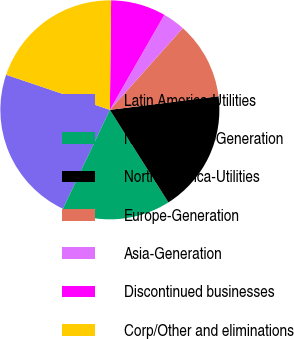Convert chart. <chart><loc_0><loc_0><loc_500><loc_500><pie_chart><fcel>Latin America-Utilities<fcel>North America-Generation<fcel>North America-Utilities<fcel>Europe-Generation<fcel>Asia-Generation<fcel>Discontinued businesses<fcel>Corp/Other and eliminations<nl><fcel>23.14%<fcel>16.03%<fcel>18.01%<fcel>11.42%<fcel>3.31%<fcel>8.11%<fcel>19.99%<nl></chart> 